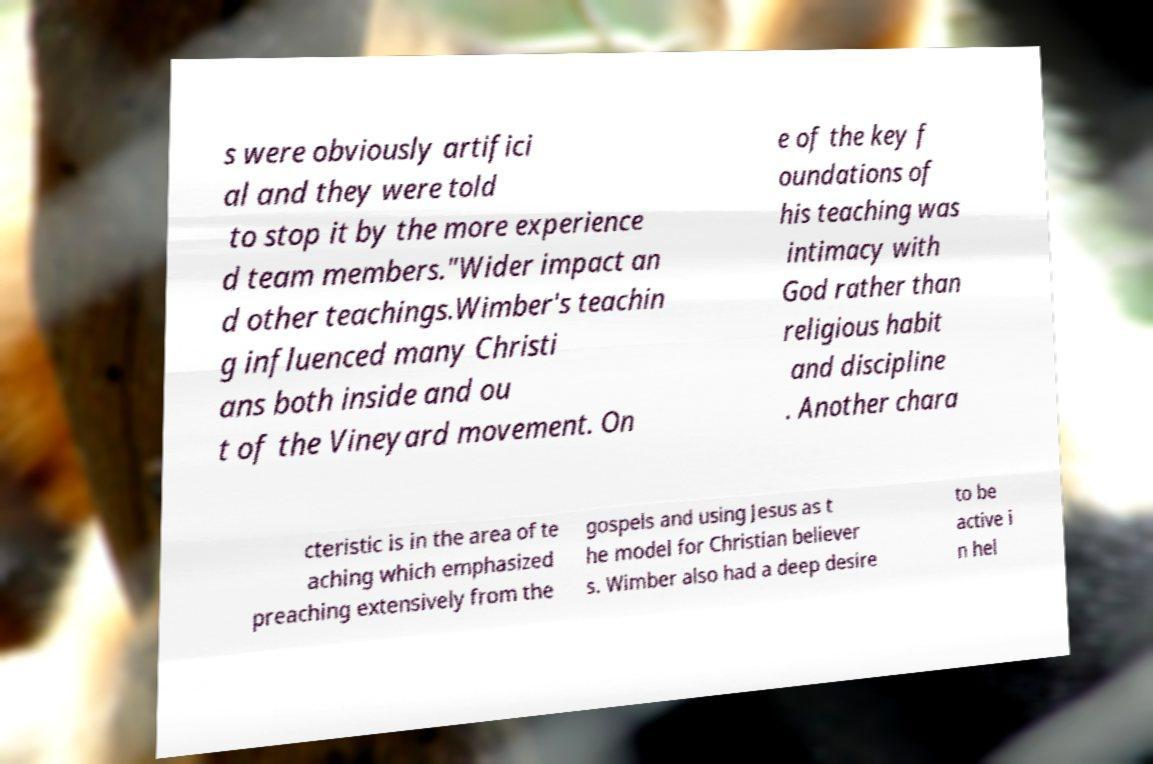I need the written content from this picture converted into text. Can you do that? s were obviously artifici al and they were told to stop it by the more experience d team members."Wider impact an d other teachings.Wimber's teachin g influenced many Christi ans both inside and ou t of the Vineyard movement. On e of the key f oundations of his teaching was intimacy with God rather than religious habit and discipline . Another chara cteristic is in the area of te aching which emphasized preaching extensively from the gospels and using Jesus as t he model for Christian believer s. Wimber also had a deep desire to be active i n hel 